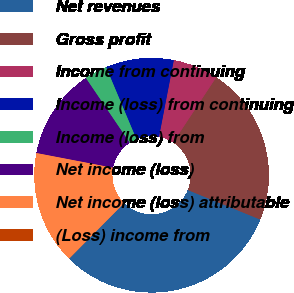Convert chart to OTSL. <chart><loc_0><loc_0><loc_500><loc_500><pie_chart><fcel>Net revenues<fcel>Gross profit<fcel>Income from continuing<fcel>Income (loss) from continuing<fcel>Income (loss) from<fcel>Net income (loss)<fcel>Net income (loss) attributable<fcel>(Loss) income from<nl><fcel>31.24%<fcel>21.87%<fcel>6.25%<fcel>9.38%<fcel>3.13%<fcel>12.5%<fcel>15.62%<fcel>0.01%<nl></chart> 